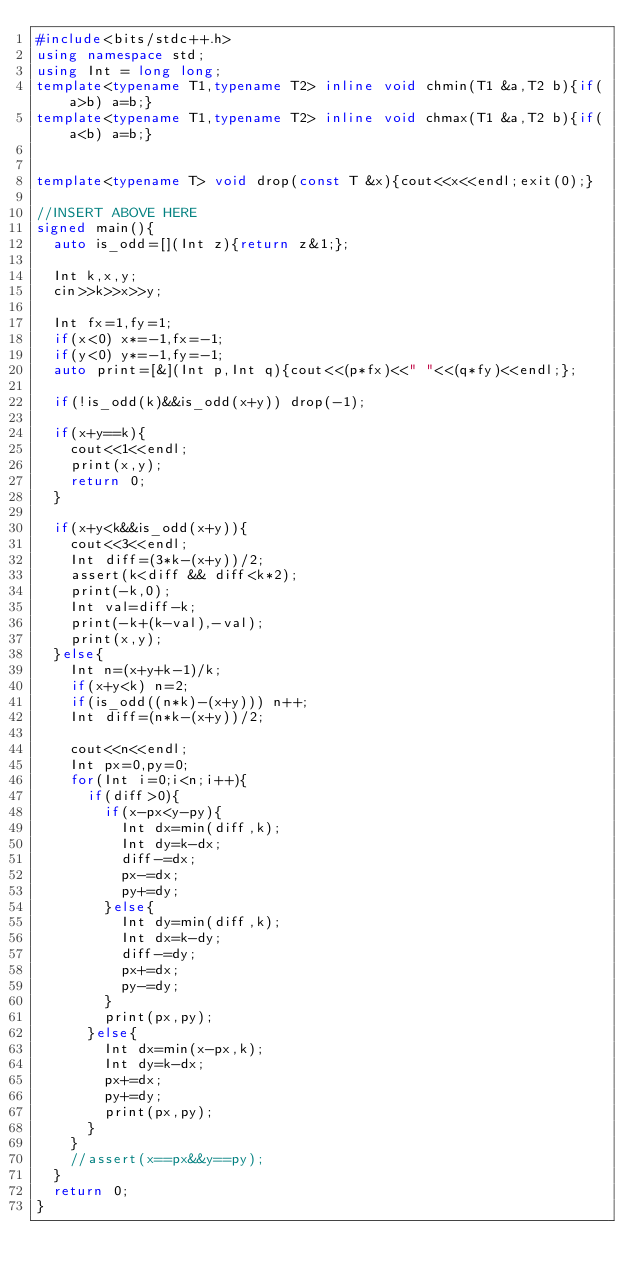Convert code to text. <code><loc_0><loc_0><loc_500><loc_500><_C++_>#include<bits/stdc++.h>
using namespace std;
using Int = long long;
template<typename T1,typename T2> inline void chmin(T1 &a,T2 b){if(a>b) a=b;}
template<typename T1,typename T2> inline void chmax(T1 &a,T2 b){if(a<b) a=b;}


template<typename T> void drop(const T &x){cout<<x<<endl;exit(0);}

//INSERT ABOVE HERE
signed main(){
  auto is_odd=[](Int z){return z&1;};

  Int k,x,y;
  cin>>k>>x>>y;

  Int fx=1,fy=1;
  if(x<0) x*=-1,fx=-1;
  if(y<0) y*=-1,fy=-1;
  auto print=[&](Int p,Int q){cout<<(p*fx)<<" "<<(q*fy)<<endl;};

  if(!is_odd(k)&&is_odd(x+y)) drop(-1);

  if(x+y==k){
    cout<<1<<endl;
    print(x,y);
    return 0;
  }

  if(x+y<k&&is_odd(x+y)){
    cout<<3<<endl;
    Int diff=(3*k-(x+y))/2;
    assert(k<diff && diff<k*2);
    print(-k,0);
    Int val=diff-k;
    print(-k+(k-val),-val);
    print(x,y);
  }else{
    Int n=(x+y+k-1)/k;
    if(x+y<k) n=2;
    if(is_odd((n*k)-(x+y))) n++;
    Int diff=(n*k-(x+y))/2;

    cout<<n<<endl;
    Int px=0,py=0;
    for(Int i=0;i<n;i++){
      if(diff>0){
        if(x-px<y-py){
          Int dx=min(diff,k);
          Int dy=k-dx;
          diff-=dx;
          px-=dx;
          py+=dy;
        }else{
          Int dy=min(diff,k);
          Int dx=k-dy;
          diff-=dy;
          px+=dx;
          py-=dy;
        }
        print(px,py);
      }else{
        Int dx=min(x-px,k);
        Int dy=k-dx;
        px+=dx;
        py+=dy;
        print(px,py);
      }
    }
    //assert(x==px&&y==py);
  }
  return 0;
}
</code> 